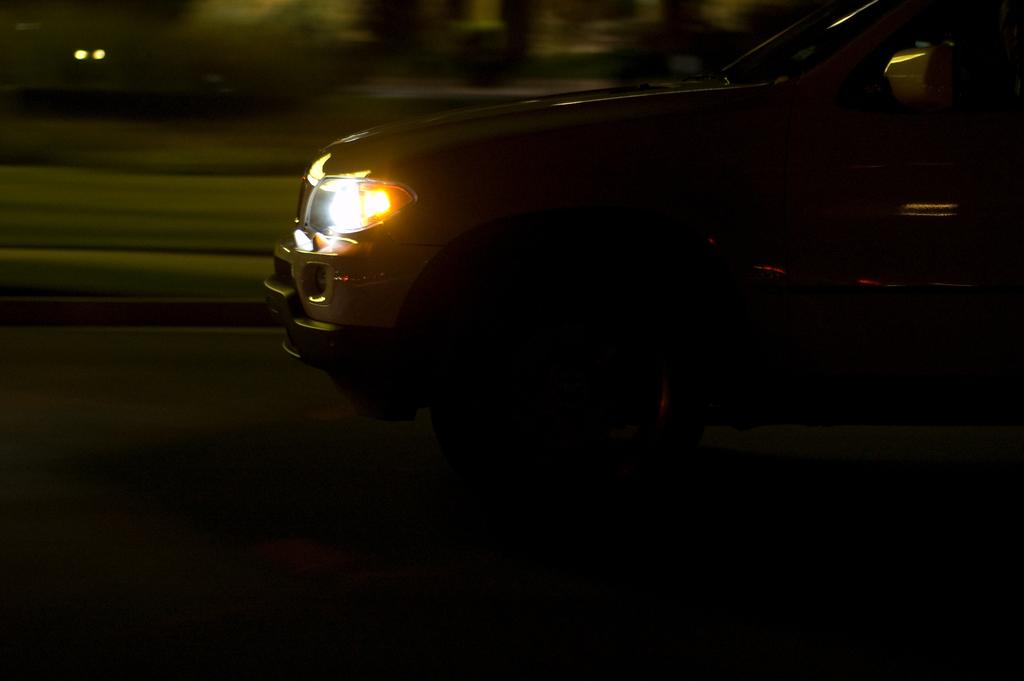What is the main subject of the image? The main subject of the image is a car. Where is the car located in the image? The car is on the road in the image. Can you describe the background of the image? The background of the image is blurred. What type of rock can be seen being carried by the van in the image? There is no van present in the image, and therefore no rock being carried. 